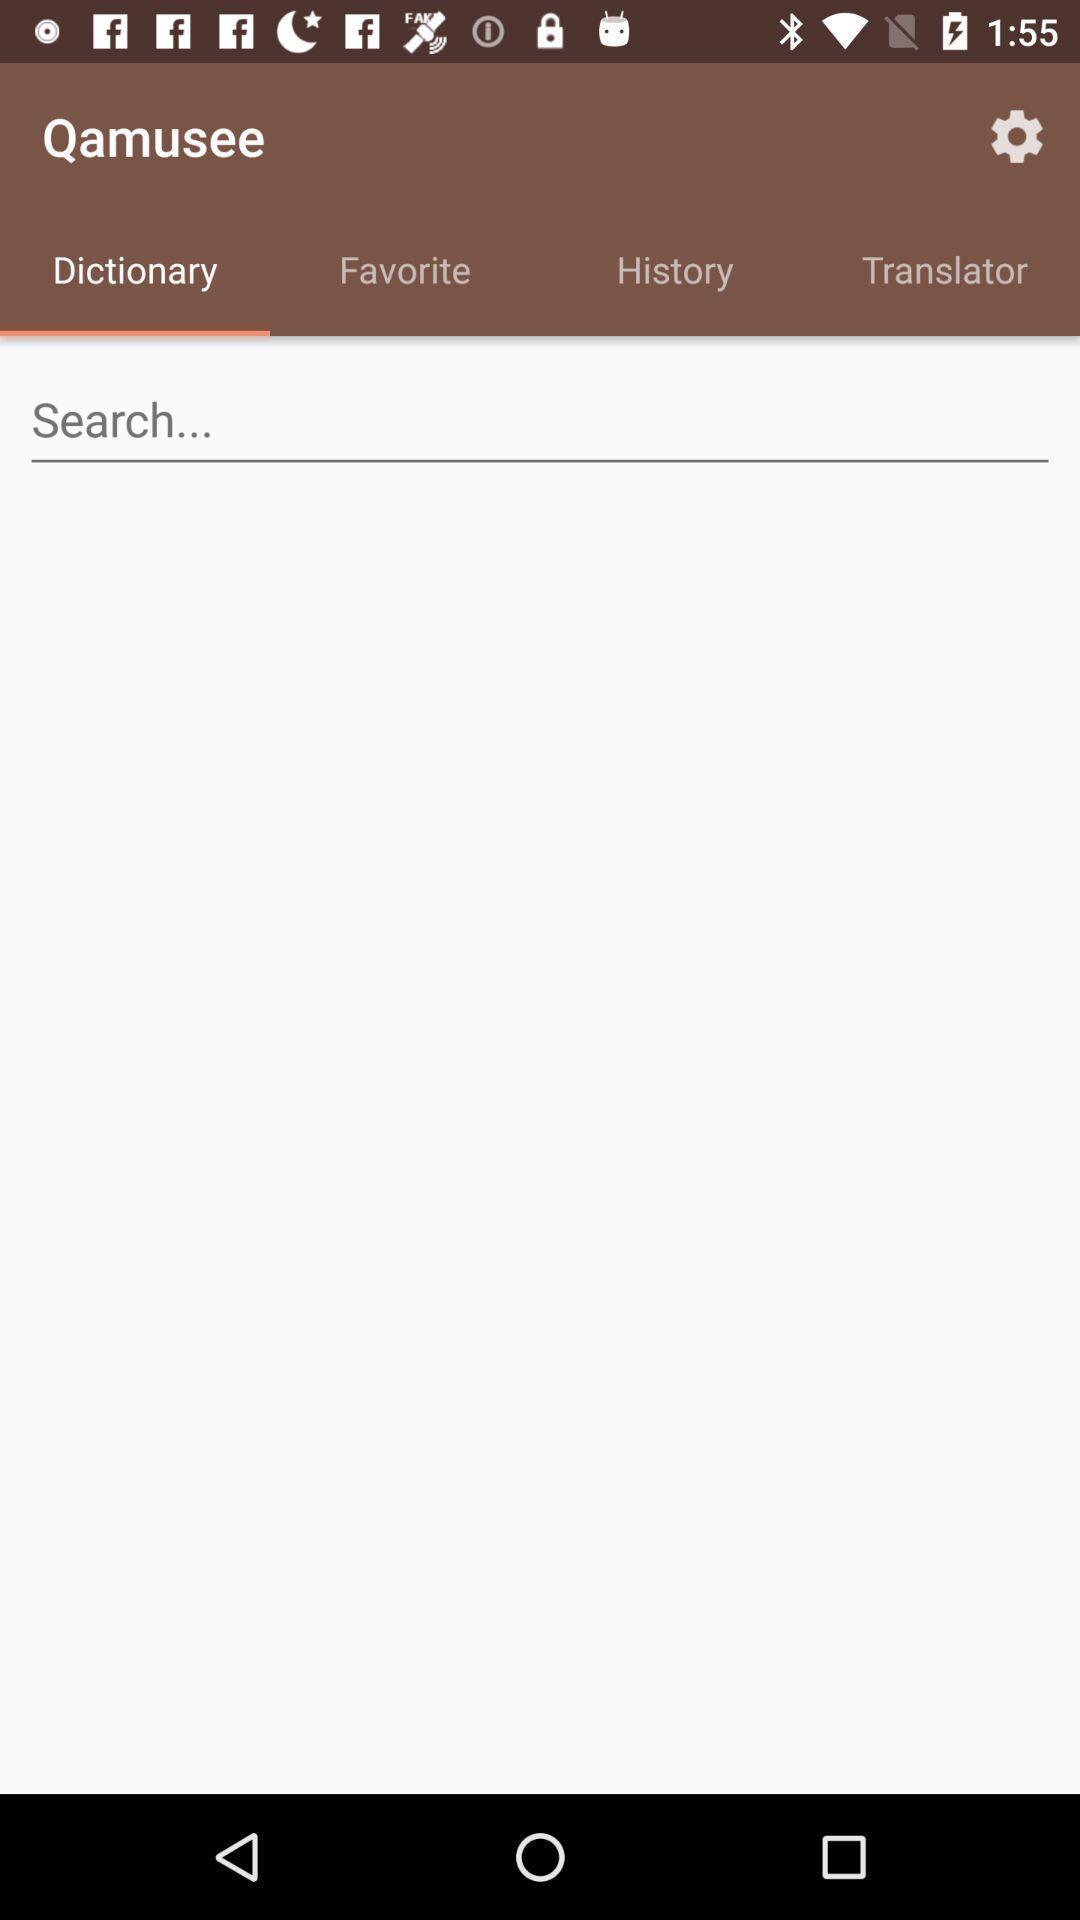Tell me what you see in this picture. Screen showing dictionary with search option. 